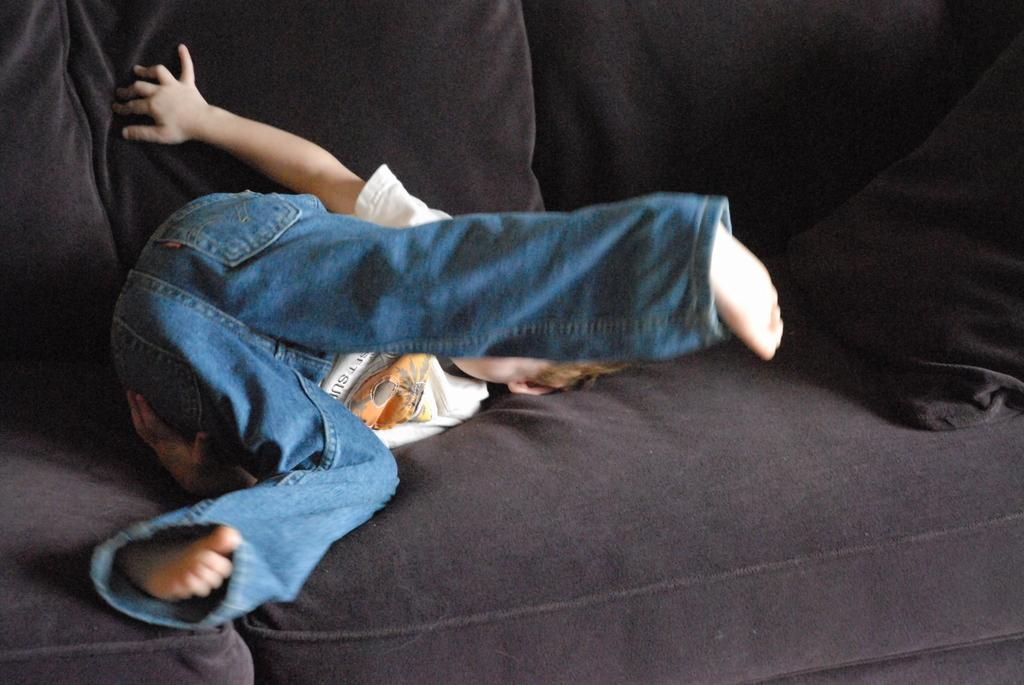Who is the main subject in the image? There is a child in the image. What is the child doing in the image? The child is lying on a couch. What else can be seen on the couch in the image? There is a pillow on the couch. What type of island can be seen in the background of the image? There is no island present in the image. 